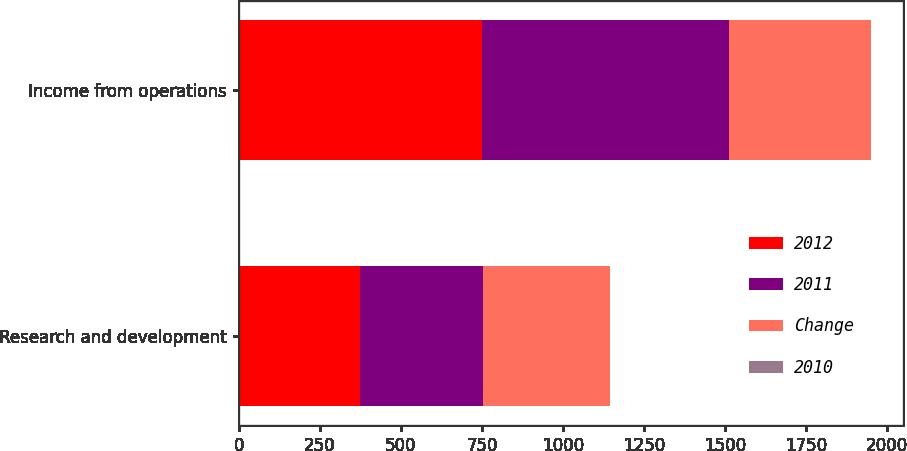Convert chart to OTSL. <chart><loc_0><loc_0><loc_500><loc_500><stacked_bar_chart><ecel><fcel>Research and development<fcel>Income from operations<nl><fcel>2012<fcel>375<fcel>751<nl><fcel>2011<fcel>379<fcel>760<nl><fcel>Change<fcel>391<fcel>438<nl><fcel>2010<fcel>1<fcel>1<nl></chart> 